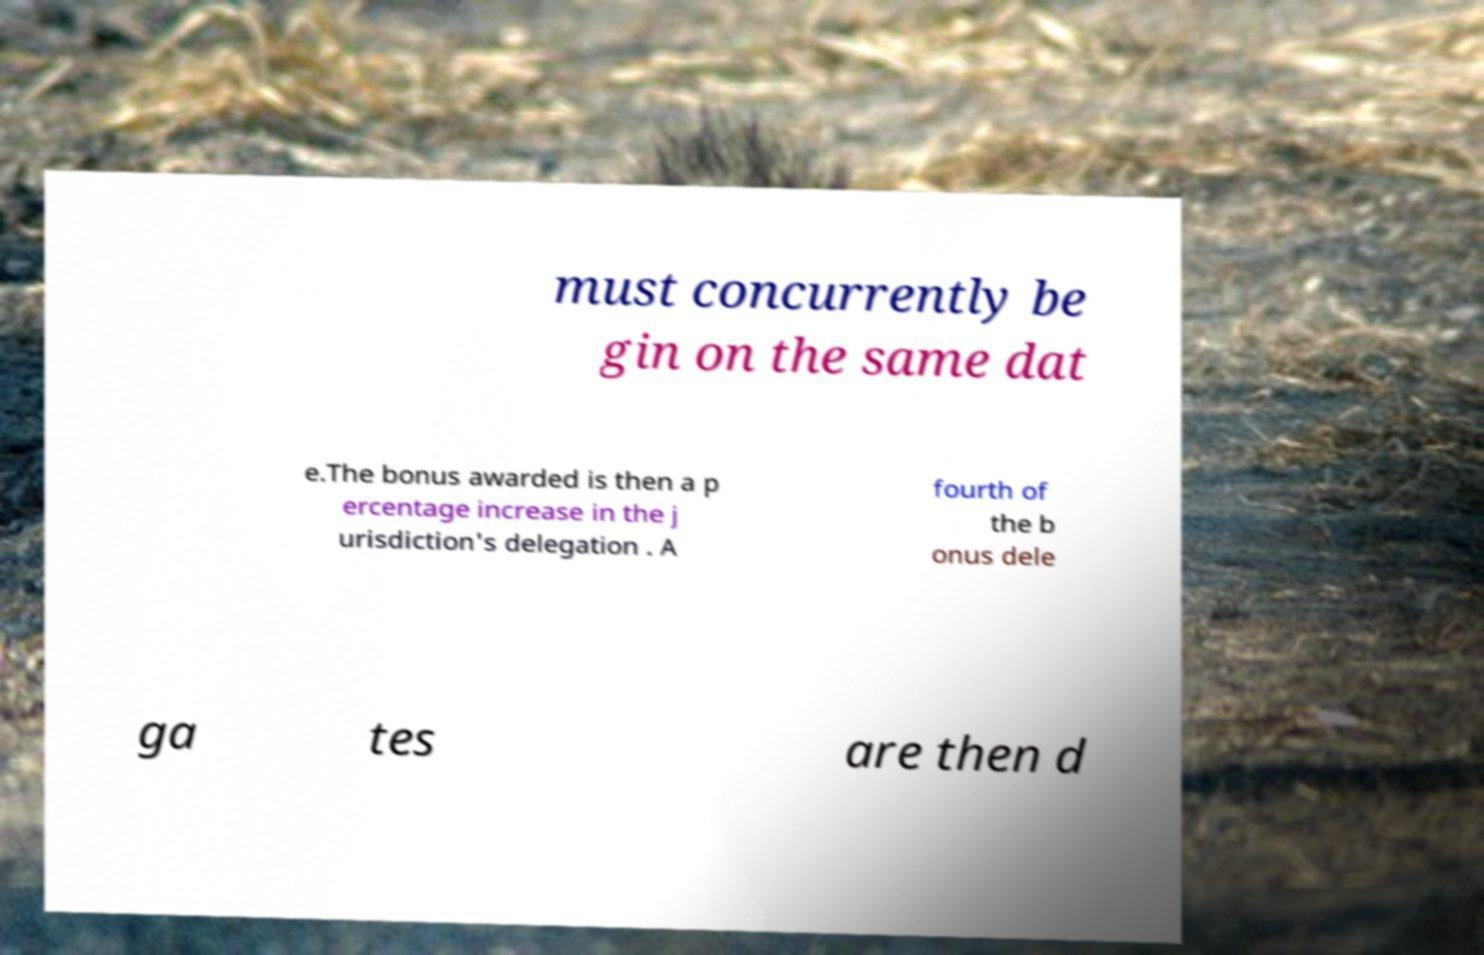For documentation purposes, I need the text within this image transcribed. Could you provide that? must concurrently be gin on the same dat e.The bonus awarded is then a p ercentage increase in the j urisdiction's delegation . A fourth of the b onus dele ga tes are then d 